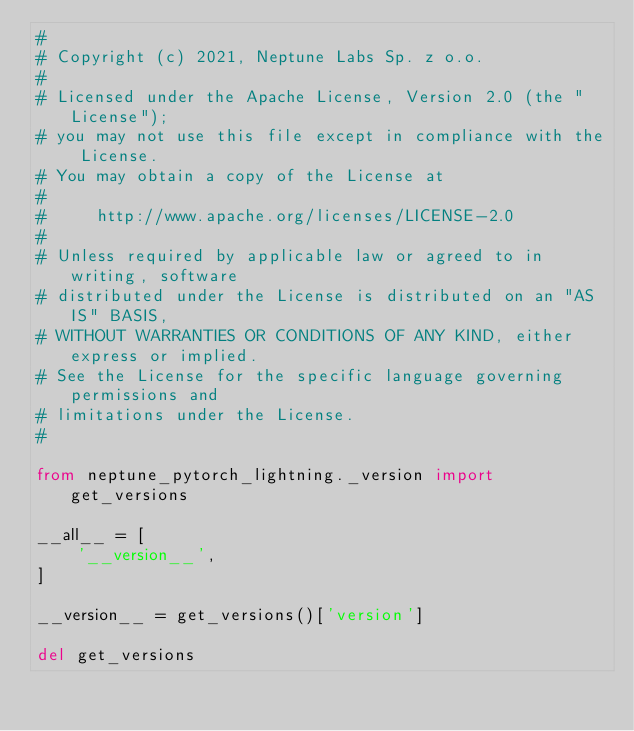Convert code to text. <code><loc_0><loc_0><loc_500><loc_500><_Python_>#
# Copyright (c) 2021, Neptune Labs Sp. z o.o.
#
# Licensed under the Apache License, Version 2.0 (the "License");
# you may not use this file except in compliance with the License.
# You may obtain a copy of the License at
#
#     http://www.apache.org/licenses/LICENSE-2.0
#
# Unless required by applicable law or agreed to in writing, software
# distributed under the License is distributed on an "AS IS" BASIS,
# WITHOUT WARRANTIES OR CONDITIONS OF ANY KIND, either express or implied.
# See the License for the specific language governing permissions and
# limitations under the License.
#

from neptune_pytorch_lightning._version import get_versions

__all__ = [
    '__version__',
]

__version__ = get_versions()['version']

del get_versions
</code> 